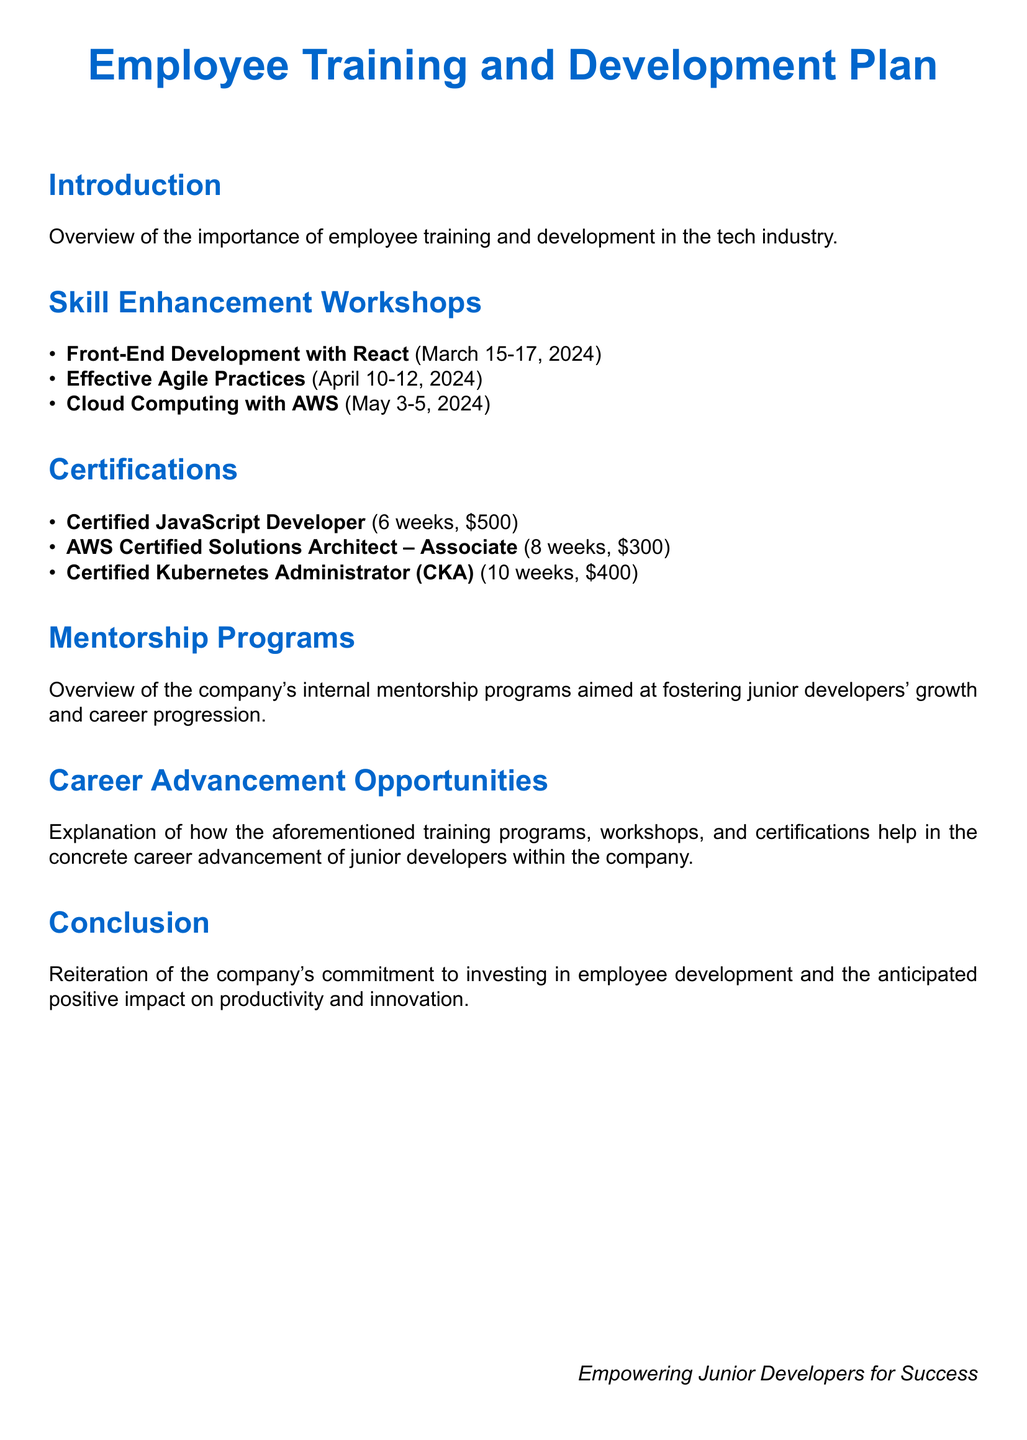what is the title of the document? The title is presented at the top of the document and specifies the main subject matter.
Answer: Employee Training and Development Plan how many skill enhancement workshops are listed? The number of workshops is indicated in the 'Skill Enhancement Workshops' section by counting the items listed.
Answer: 3 what is the date for the Front-End Development with React workshop? The date of the workshop is specified in a parenthetical format next to the workshop title.
Answer: March 15-17, 2024 how long is the Certified JavaScript Developer certification? The duration is provided next to the certification title as a specific time frame.
Answer: 6 weeks what is the cost of the AWS Certified Solutions Architect – Associate certification? The cost is mentioned next to the certification title, allowing for easy retrieval of financial information.
Answer: $300 which workshop focuses on Agile practices? The relevant workshop is highlighted in the 'Skill Enhancement Workshops' section, showcasing its focus area.
Answer: Effective Agile Practices how many weeks is the Certified Kubernetes Administrator program? The number of weeks is found beside the certification title in the document.
Answer: 10 weeks what section describes mentorship programs? This section is specifically named in the table of contents and highlights the focus of the content.
Answer: Mentorship Programs what is emphasized in the conclusion of the document? The conclusion reiterates a specific commitment, which is stated at the end of the document.
Answer: employee development 